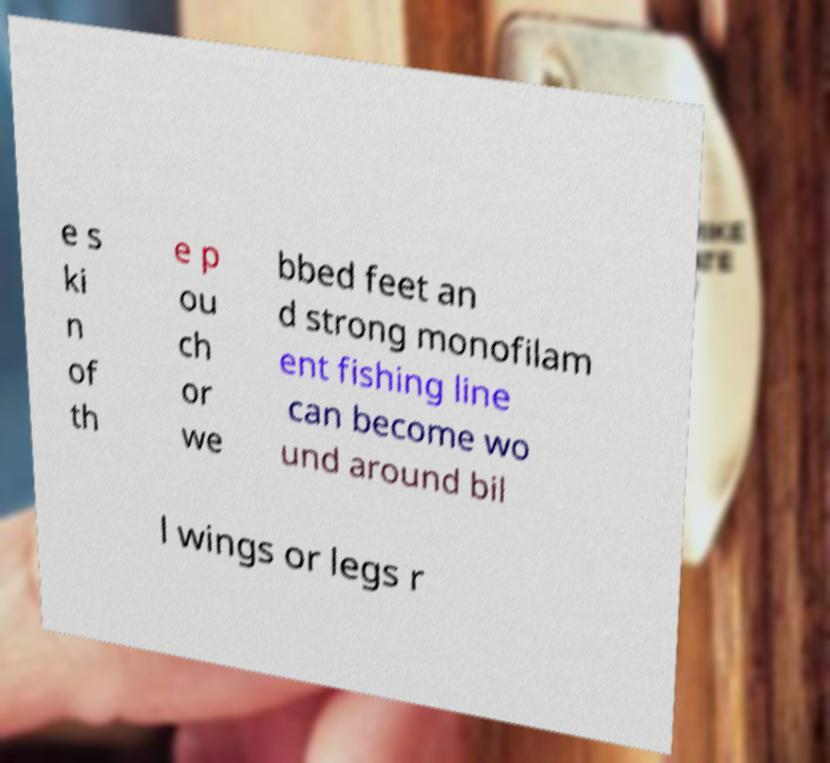Could you extract and type out the text from this image? e s ki n of th e p ou ch or we bbed feet an d strong monofilam ent fishing line can become wo und around bil l wings or legs r 